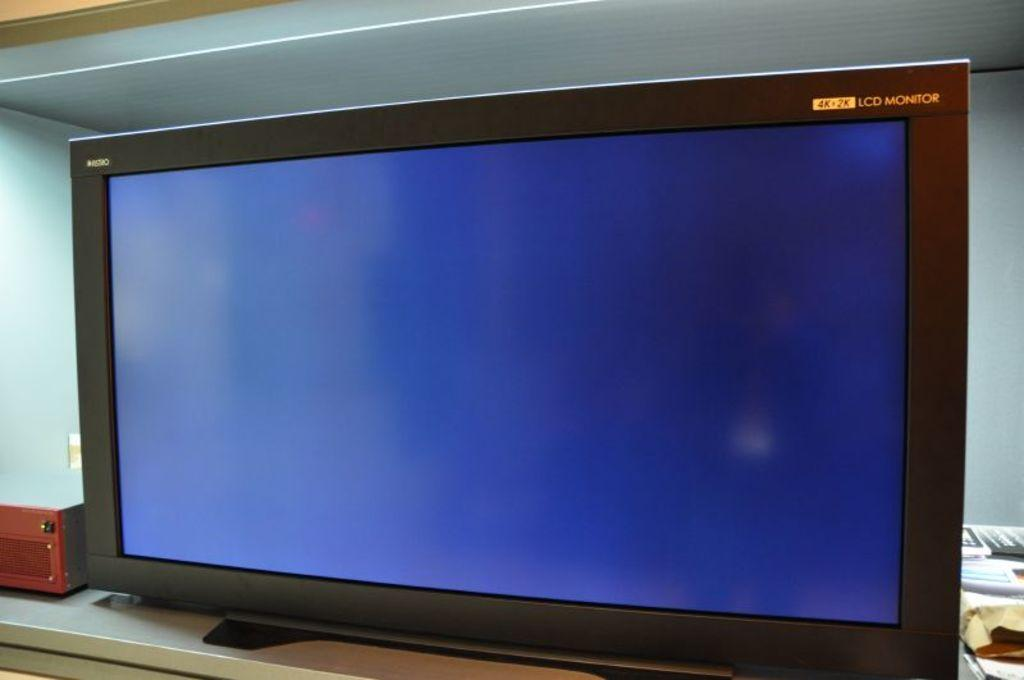<image>
Provide a brief description of the given image. A black 4k+2k LCD monitor with a blue screen 